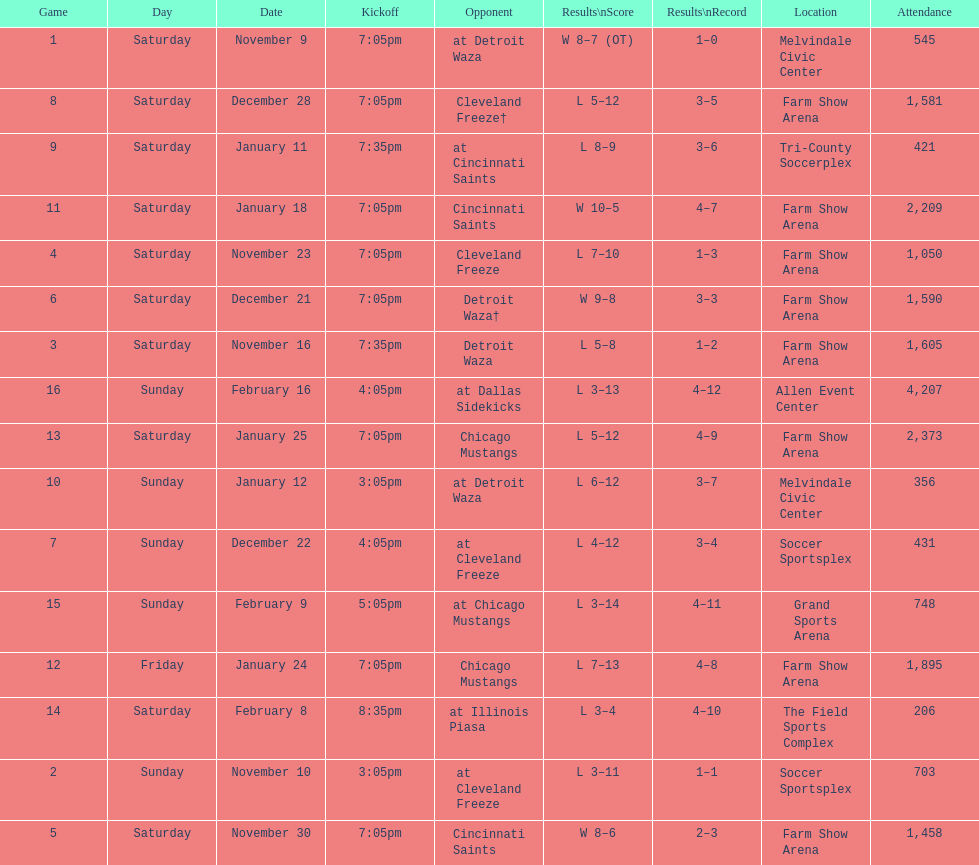Which opponent is listed first in the table? Detroit Waza. 